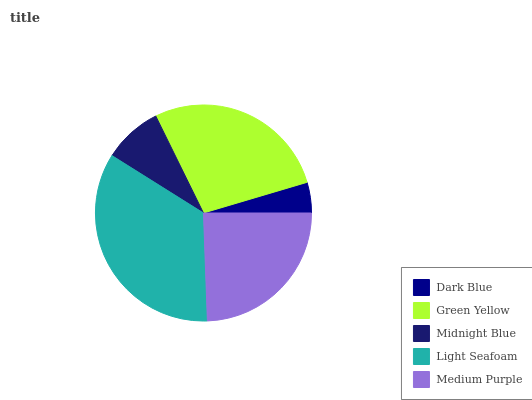Is Dark Blue the minimum?
Answer yes or no. Yes. Is Light Seafoam the maximum?
Answer yes or no. Yes. Is Green Yellow the minimum?
Answer yes or no. No. Is Green Yellow the maximum?
Answer yes or no. No. Is Green Yellow greater than Dark Blue?
Answer yes or no. Yes. Is Dark Blue less than Green Yellow?
Answer yes or no. Yes. Is Dark Blue greater than Green Yellow?
Answer yes or no. No. Is Green Yellow less than Dark Blue?
Answer yes or no. No. Is Medium Purple the high median?
Answer yes or no. Yes. Is Medium Purple the low median?
Answer yes or no. Yes. Is Midnight Blue the high median?
Answer yes or no. No. Is Midnight Blue the low median?
Answer yes or no. No. 